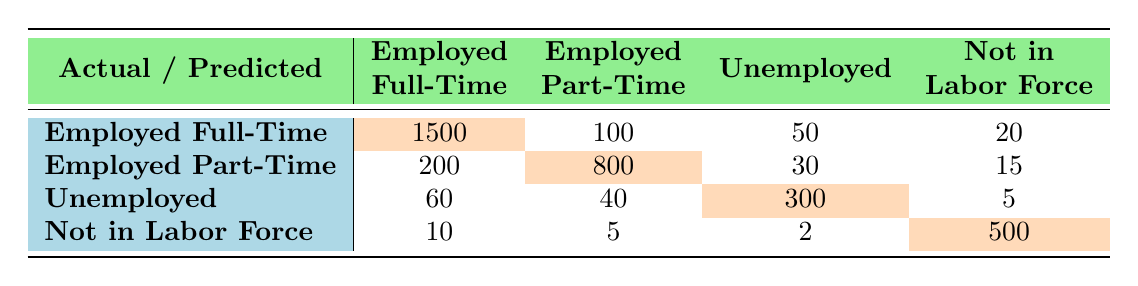What is the count of individuals who are classified as "Employed Full-Time" and predicted as such? Referring to the table, the cell corresponding to "Employed Full-Time" and "Employed Full-Time" shows the count of 1500.
Answer: 1500 How many individuals were predicted to be "Unemployed" but were actually "Employed Part-Time"? In the table, the corresponding cell for "Employed Part-Time" and "Unemployed" indicates a count of 30.
Answer: 30 What is the total number of individuals who are "Not in Labor Force" based on the predictions? To find this, sum the values from the "Not in Labor Force" row: 10 (Employed Full-Time) + 5 (Employed Part-Time) + 2 (Unemployed) + 500 (Not in Labor Force) = 517.
Answer: 517 Is it true that more individuals classified as "Unemployed" were predicted as "Unemployed" than "Not in Labor Force"? From the table, individuals classified as "Unemployed" and predicted as "Unemployed" is 300, while predicted as "Not in Labor Force" is 5. Since 300 is greater than 5, the statement is true.
Answer: Yes How many individuals classified as "Employed Full-Time" were incorrectly predicted as "Not in Labor Force"? The table indicates that 20 individuals classified as "Employed Full-Time" were predicted to be "Not in Labor Force."
Answer: 20 What percentage of those who were actually "Unemployed" were predicted correctly? The number of correct predictions for "Unemployed" is 300. The total number of individuals classified as "Unemployed" is 60 + 40 + 300 + 5 = 405. The percentage is (300 / 405) * 100 ≈ 74.07%.
Answer: 74.07% How many individuals predicted as "Employed Full-Time" among the "Not in Labor Force"? The table shows that 10 individuals classified as "Not in Labor Force" were predicted as "Employed Full-Time."
Answer: 10 What is the difference between the number of individuals classified as "Unemployed" who were predicted as "Employed Full-Time" and those who were predicted as "Unemployed"? The number predicted as "Employed Full-Time" is 60, and the number predicted as "Unemployed" is 300, so the difference is 300 - 60 = 240.
Answer: 240 How many individuals classified as "Employed Part-Time" were predicted incorrectly? The incorrect predictions for "Employed Part-Time" are 200 (predicted as Full-Time) + 30 (predicted as Unemployed) + 15 (predicted as Not in Labor Force) = 245.
Answer: 245 